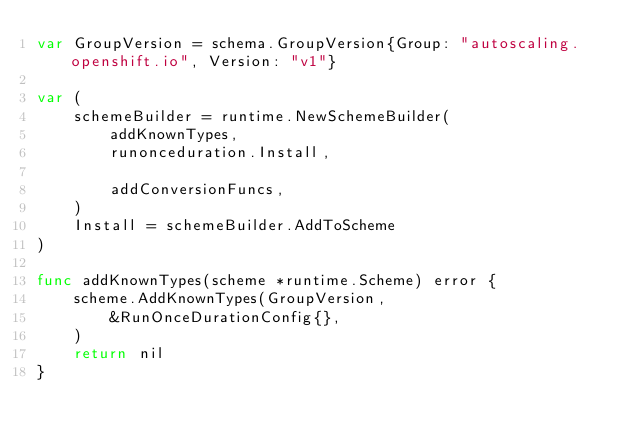Convert code to text. <code><loc_0><loc_0><loc_500><loc_500><_Go_>var GroupVersion = schema.GroupVersion{Group: "autoscaling.openshift.io", Version: "v1"}

var (
	schemeBuilder = runtime.NewSchemeBuilder(
		addKnownTypes,
		runonceduration.Install,

		addConversionFuncs,
	)
	Install = schemeBuilder.AddToScheme
)

func addKnownTypes(scheme *runtime.Scheme) error {
	scheme.AddKnownTypes(GroupVersion,
		&RunOnceDurationConfig{},
	)
	return nil
}
</code> 